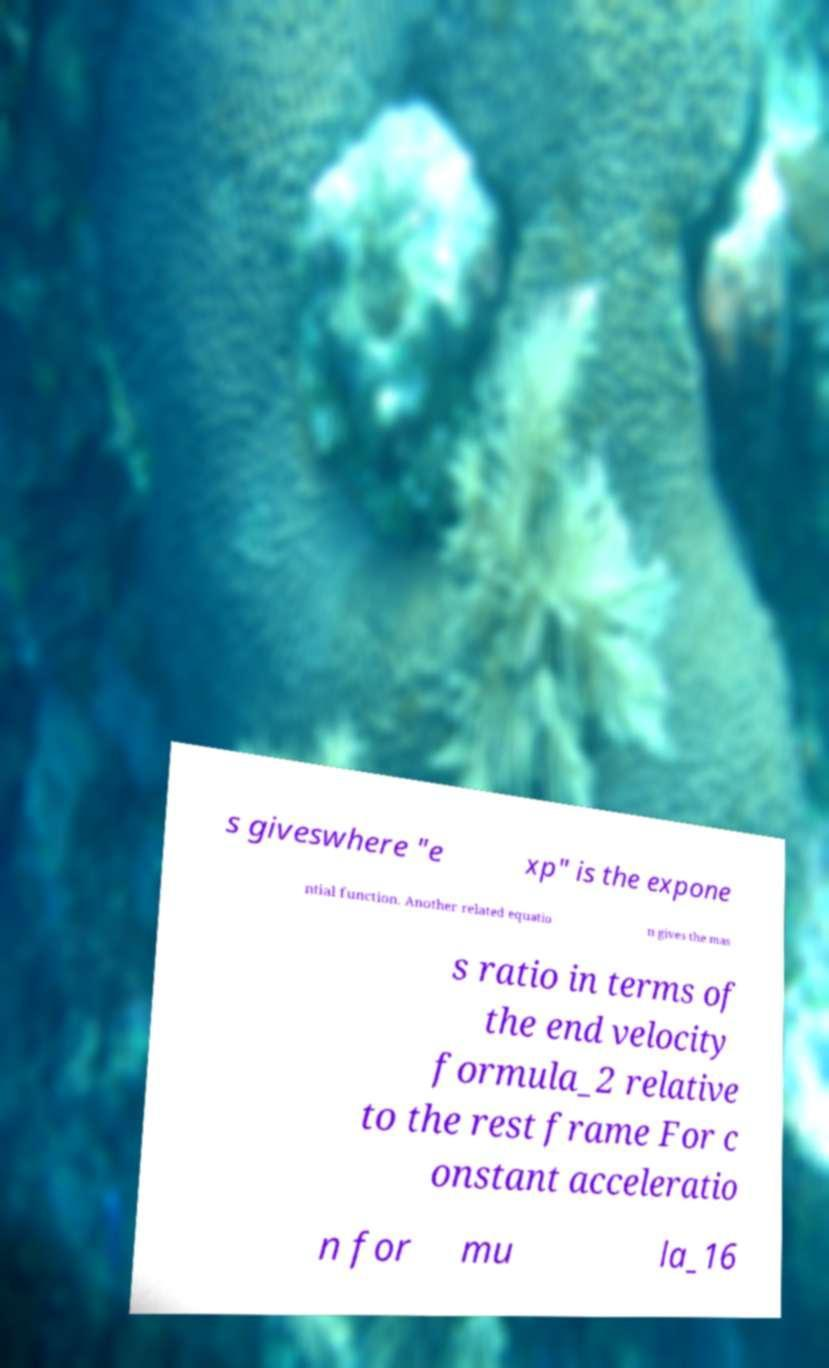Can you read and provide the text displayed in the image?This photo seems to have some interesting text. Can you extract and type it out for me? s giveswhere "e xp" is the expone ntial function. Another related equatio n gives the mas s ratio in terms of the end velocity formula_2 relative to the rest frame For c onstant acceleratio n for mu la_16 